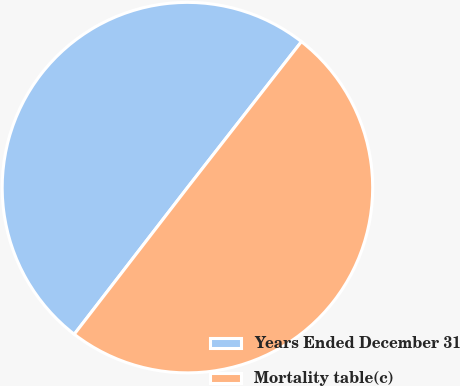Convert chart. <chart><loc_0><loc_0><loc_500><loc_500><pie_chart><fcel>Years Ended December 31<fcel>Mortality table(c)<nl><fcel>50.09%<fcel>49.91%<nl></chart> 